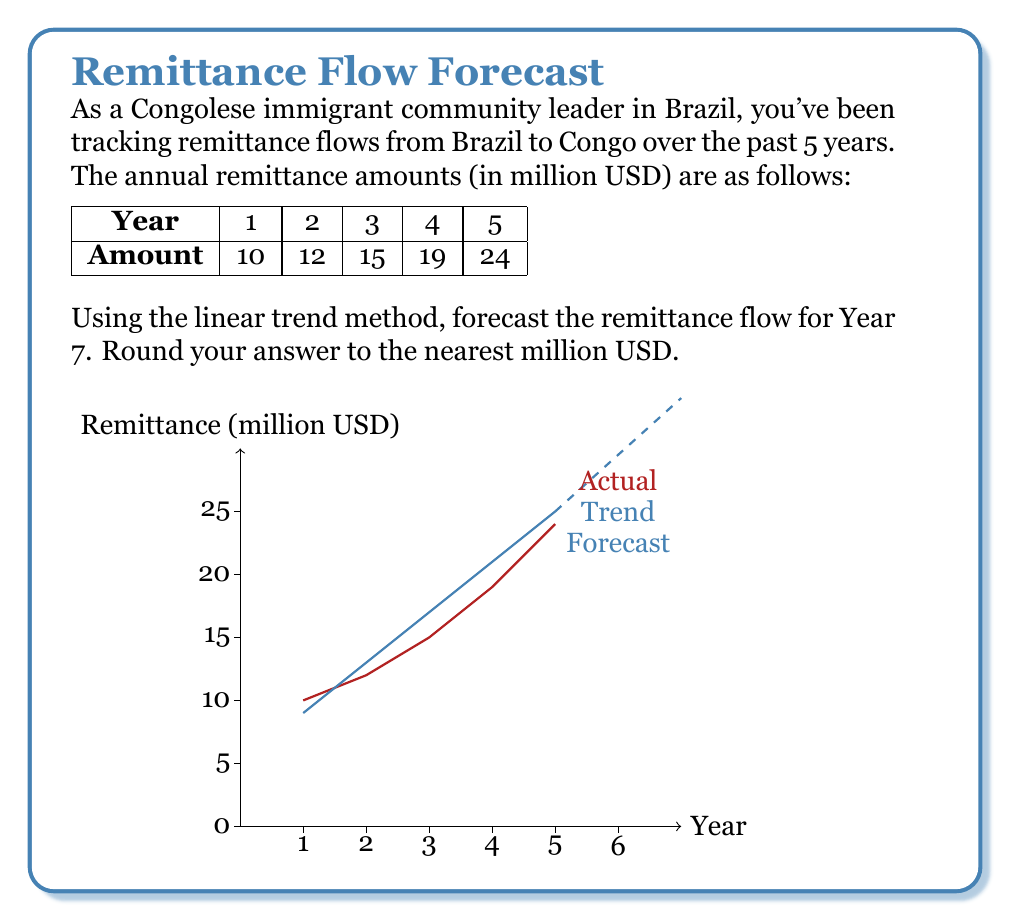Teach me how to tackle this problem. To forecast the remittance flow using the linear trend method, we need to follow these steps:

1) First, let's set up our time variable t:
   Year 1: t = -2
   Year 2: t = -1
   Year 3: t = 0 (middle year)
   Year 4: t = 1
   Year 5: t = 2

2) Calculate the average remittance (a):
   $$a = \frac{10 + 12 + 15 + 19 + 24}{5} = 16$$ million USD

3) Calculate the trend slope (b):
   $$b = \frac{\sum{ty}}{\sum{t^2}}$$
   where y is the remittance amount.

   $$\sum{ty} = (-2 \times 10) + (-1 \times 12) + (0 \times 15) + (1 \times 19) + (2 \times 24) = 35$$
   $$\sum{t^2} = (-2)^2 + (-1)^2 + 0^2 + 1^2 + 2^2 = 10$$

   $$b = \frac{35}{10} = 3.5$$ million USD per year

4) The linear trend equation is:
   $$Y = a + bt$$
   where Y is the forecasted remittance, and t is the time variable.

5) For Year 7, t = 4 (2 years after the last observed year)

6) Plugging into our equation:
   $$Y = 16 + 3.5(4) = 16 + 14 = 30$$ million USD

7) Rounding to the nearest million:
   30 million USD
Answer: 30 million USD 